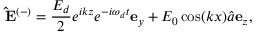Convert formula to latex. <formula><loc_0><loc_0><loc_500><loc_500>\hat { E } ^ { ( - ) } = \frac { E _ { d } } { 2 } e ^ { i k z } e ^ { - i \omega _ { d } t } e _ { y } + E _ { 0 } \cos ( k x ) \hat { a } e _ { z } ,</formula> 